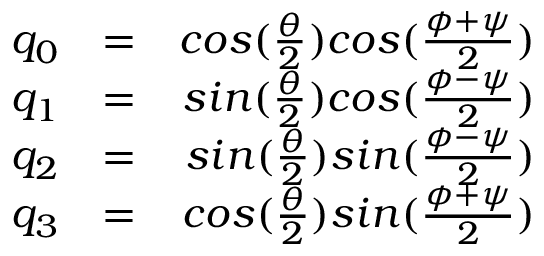<formula> <loc_0><loc_0><loc_500><loc_500>\begin{array} { r l r } { q _ { 0 } } & { = } & { \cos ( \frac { \theta } { 2 } ) \cos ( \frac { \phi + \psi } { 2 } ) } \\ { q _ { 1 } } & { = } & { \sin ( \frac { \theta } { 2 } ) \cos ( \frac { \phi - \psi } { 2 } ) } \\ { q _ { 2 } } & { = } & { \sin ( \frac { \theta } { 2 } ) \sin ( \frac { \phi - \psi } { 2 } ) } \\ { q _ { 3 } } & { = } & { \cos ( \frac { \theta } { 2 } ) \sin ( \frac { \phi + \psi } { 2 } ) } \end{array}</formula> 